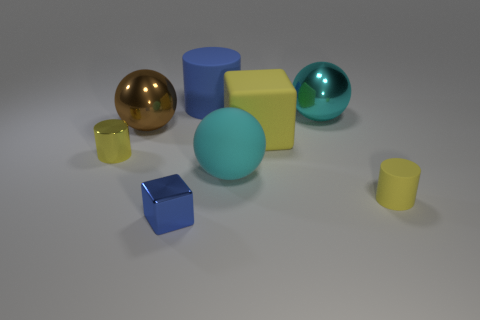Add 2 big matte balls. How many objects exist? 10 Subtract all cylinders. How many objects are left? 5 Subtract all tiny yellow metallic cylinders. Subtract all brown things. How many objects are left? 6 Add 7 tiny cylinders. How many tiny cylinders are left? 9 Add 7 cylinders. How many cylinders exist? 10 Subtract 0 yellow spheres. How many objects are left? 8 